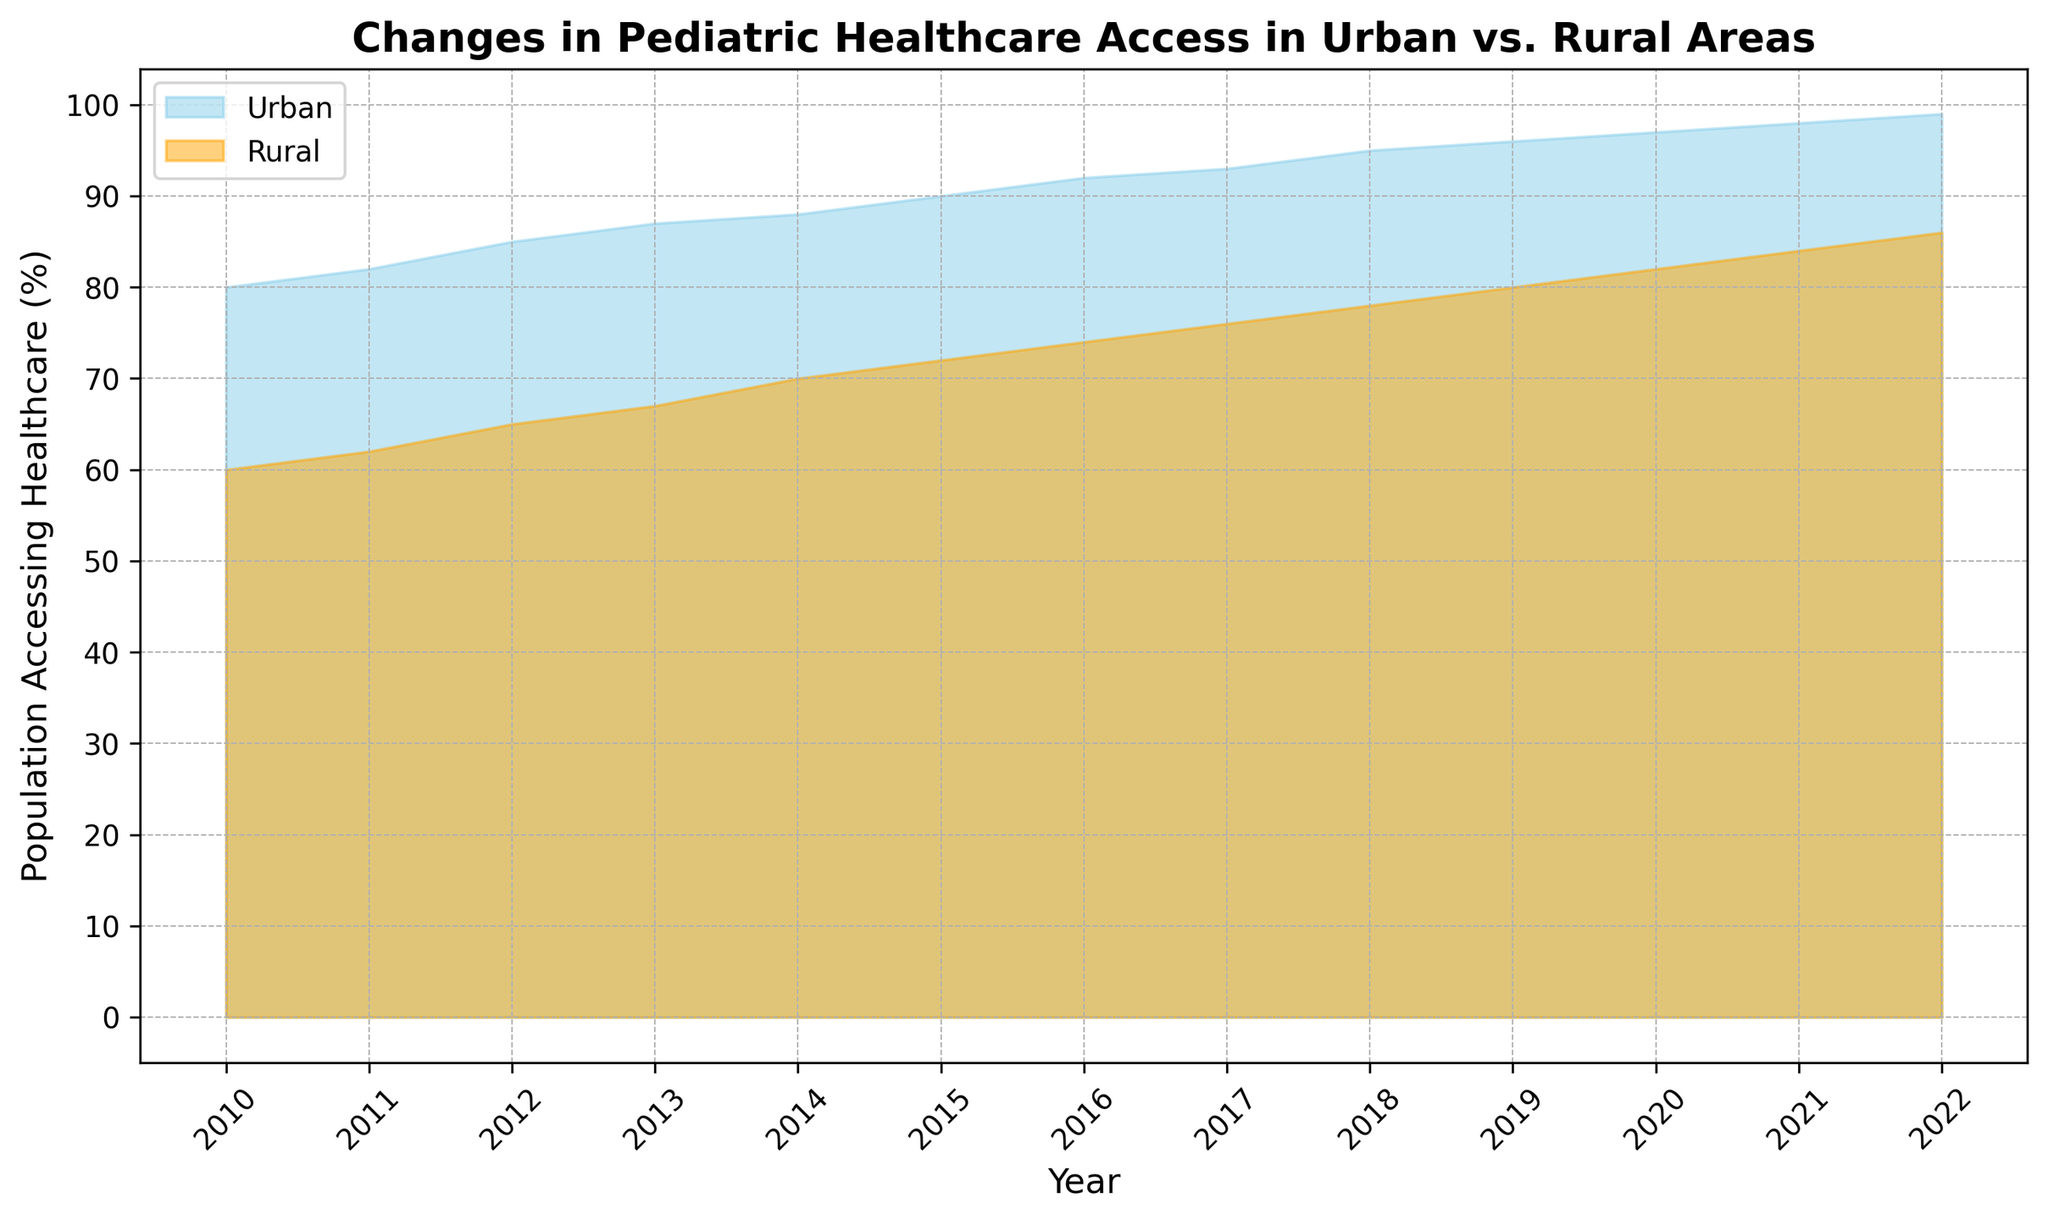Which area's pediatric healthcare access increased more between 2010 and 2022? To determine this, we compare the increase in healthcare access for urban and rural areas from 2010 to 2022. For urban areas, the increase is from 80% to 99%, which is 99 - 80 = 19 percentage points. For rural areas, the increase is from 60% to 86%, which is 86 - 60 = 26 percentage points.
Answer: Rural areas What is the average percentage of urban population accessing healthcare from 2010 to 2022? Add the urban percentages from each year between 2010 and 2022, then divide by the number of years (which is 13). So, (80 + 82 + 85 + 87 + 88 + 90 + 92 + 93 + 95 + 96 + 97 + 98 + 99) / 13 = 92.31 (rounded to 2 decimal places).
Answer: 92.31% In which year did both urban and rural populations see a rise in healthcare access simultaneously? Check the data year by year to see when both urban and rural percentages increased compared to the previous year. One such example is between 2011 and 2012, where urban access increased from 82% to 85% and rural access increased from 62% to 65%. This pattern repeats for several other years as well.
Answer: Multiple years (including 2011-2012) How much greater was the percentage of urban than rural pediatric healthcare access in 2015? Subtract the rural percentage from the urban percentage for the year 2015. So, it's 90% (urban) - 72% (rural) = 18%.
Answer: 18% Did the gap between urban and rural healthcare access increase or decrease from 2010 to 2022? Calculate the gap in 2010 and 2022, then compare the two. In 2010, the gap was 80% - 60% = 20%. In 2022, the gap was 99% - 86% = 13%. The gap has decreased.
Answer: Decreased By what percentage did rural populations' access to healthcare increase from 2018 to 2022? Subtract the percentage in 2018 from the percentage in 2022. So, it's 86% (2022) - 78% (2018) = 8%.
Answer: 8% In which year did urban areas reach at least 95% population accessing healthcare for the first time? Scan through the urban healthcare percentages year by year until you find 95% or more. It's first reached in the year 2018.
Answer: 2018 Considering both urban and rural areas, which saw the steadiest annual increase in healthcare access from 2010 to 2022? By scanning the data visually, both urban and rural areas show steady increases, but the increments in rural areas are slightly more consistent year over year, with increases mostly around 2 percentage points, compared to slightly varying increases in urban areas.
Answer: Rural areas 